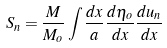Convert formula to latex. <formula><loc_0><loc_0><loc_500><loc_500>S _ { n } = \frac { M } { M _ { o } } \int { \frac { d x } { a } \frac { d \eta _ { o } } { d x } \frac { d u _ { n } } { d x } }</formula> 